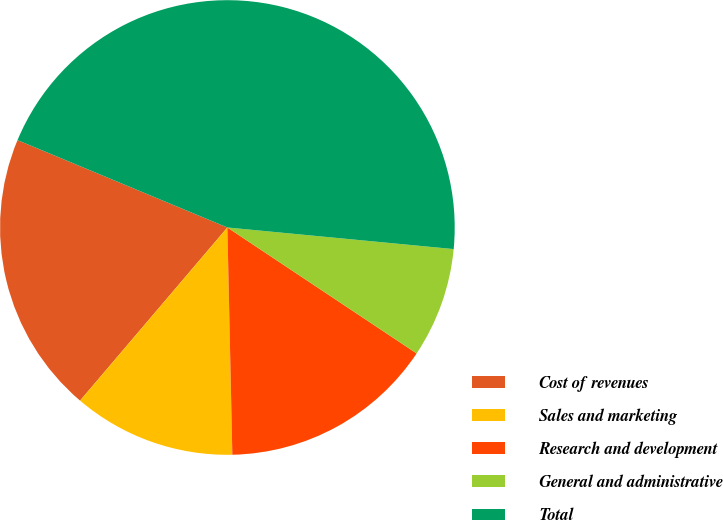Convert chart to OTSL. <chart><loc_0><loc_0><loc_500><loc_500><pie_chart><fcel>Cost of revenues<fcel>Sales and marketing<fcel>Research and development<fcel>General and administrative<fcel>Total<nl><fcel>20.06%<fcel>11.57%<fcel>15.31%<fcel>7.83%<fcel>45.24%<nl></chart> 